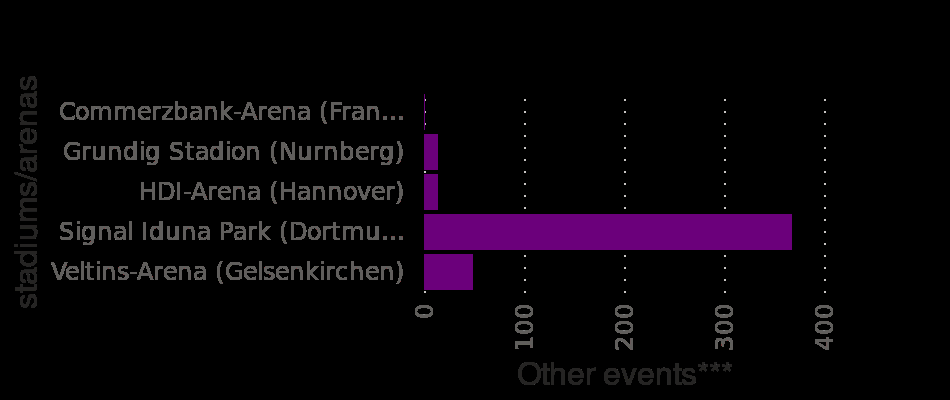<image>
What country has the highest number of visits to the Christmas Market? Germany. Where did the most events take place in the first half of 2013? Signal lndua Park stadium in Germany. What does the x-axis represent in the bar chart?  The x-axis represents "Other events." 